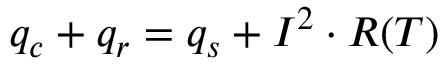<formula> <loc_0><loc_0><loc_500><loc_500>\begin{array} { r } { q _ { c } + q _ { r } = q _ { s } + I ^ { 2 } \cdot R ( T ) } \end{array}</formula> 